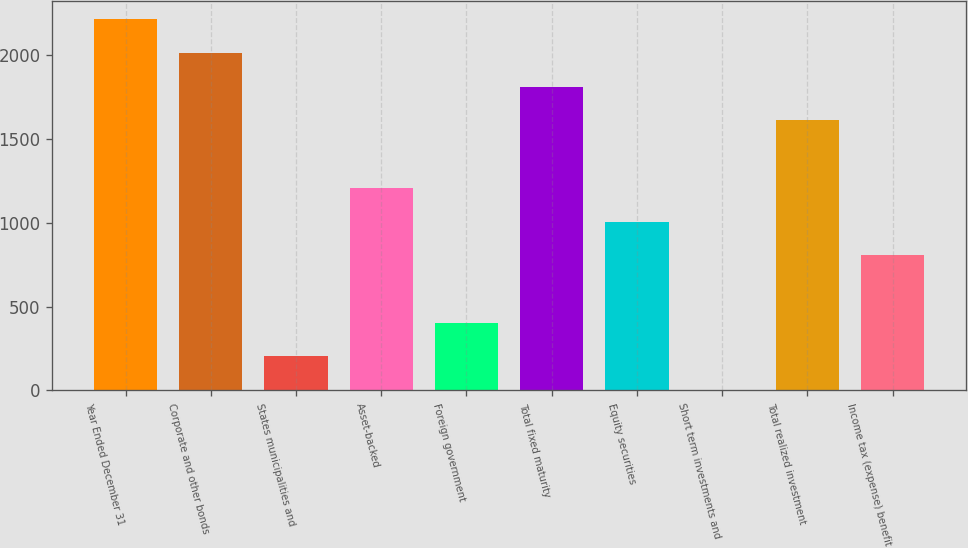Convert chart to OTSL. <chart><loc_0><loc_0><loc_500><loc_500><bar_chart><fcel>Year Ended December 31<fcel>Corporate and other bonds<fcel>States municipalities and<fcel>Asset-backed<fcel>Foreign government<fcel>Total fixed maturity<fcel>Equity securities<fcel>Short term investments and<fcel>Total realized investment<fcel>Income tax (expense) benefit<nl><fcel>2213<fcel>2012<fcel>203<fcel>1208<fcel>404<fcel>1811<fcel>1007<fcel>2<fcel>1610<fcel>806<nl></chart> 